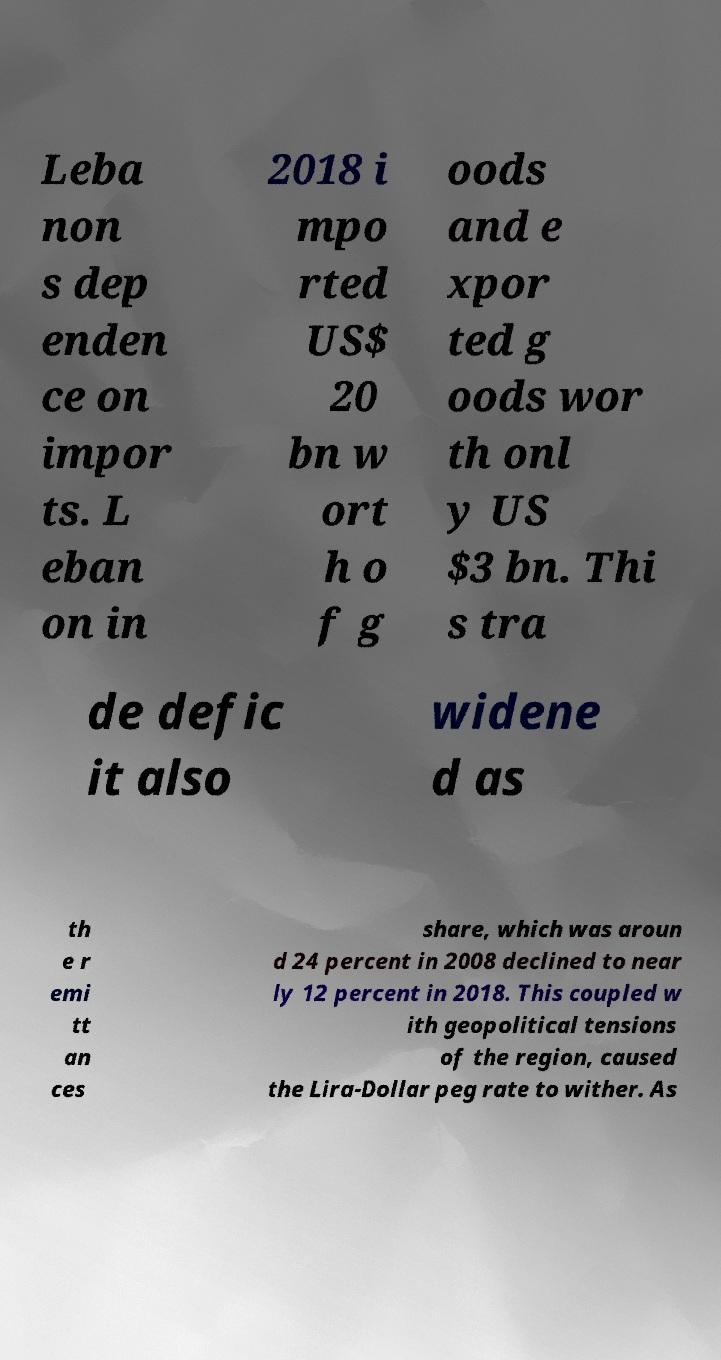What messages or text are displayed in this image? I need them in a readable, typed format. Leba non s dep enden ce on impor ts. L eban on in 2018 i mpo rted US$ 20 bn w ort h o f g oods and e xpor ted g oods wor th onl y US $3 bn. Thi s tra de defic it also widene d as th e r emi tt an ces share, which was aroun d 24 percent in 2008 declined to near ly 12 percent in 2018. This coupled w ith geopolitical tensions of the region, caused the Lira-Dollar peg rate to wither. As 